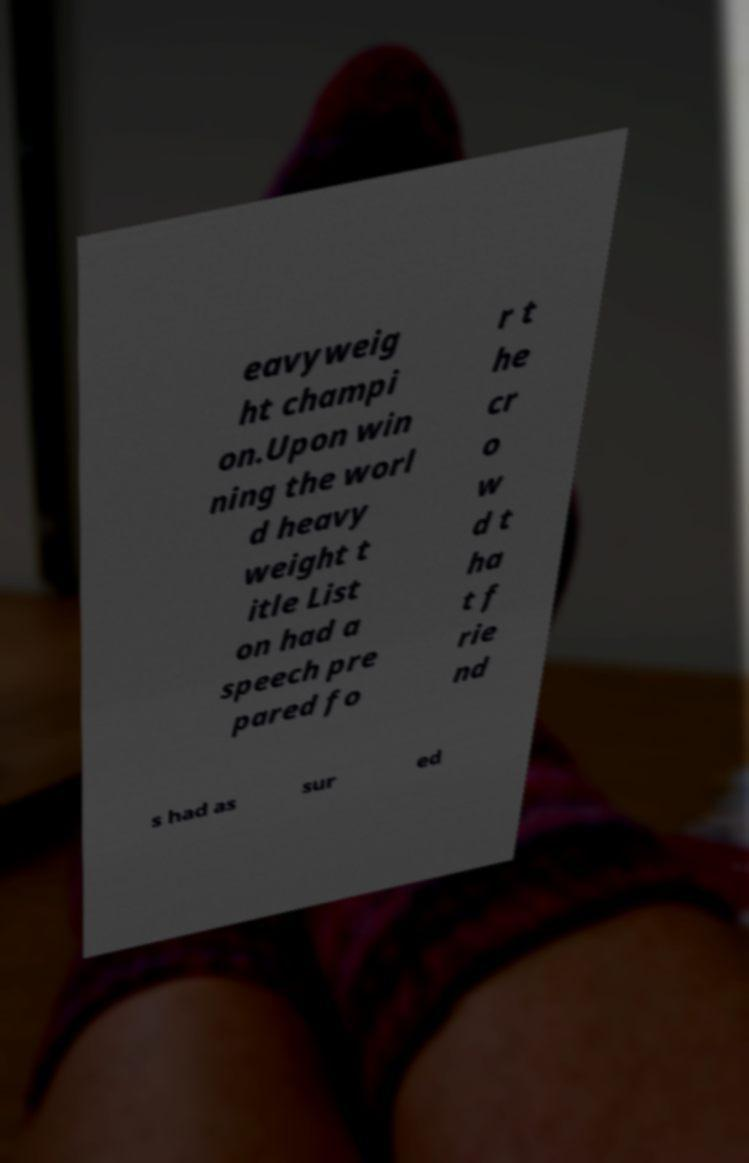What messages or text are displayed in this image? I need them in a readable, typed format. eavyweig ht champi on.Upon win ning the worl d heavy weight t itle List on had a speech pre pared fo r t he cr o w d t ha t f rie nd s had as sur ed 